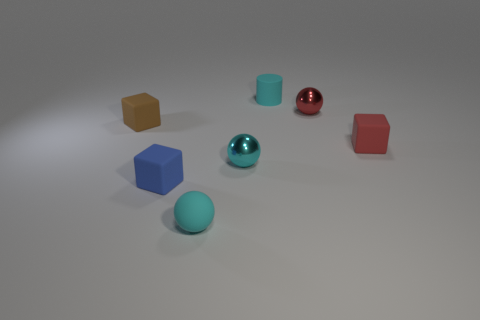Add 3 small blue matte cubes. How many objects exist? 10 Subtract all balls. How many objects are left? 4 Add 1 tiny blue matte cubes. How many tiny blue matte cubes exist? 2 Subtract 0 green blocks. How many objects are left? 7 Subtract all small rubber cubes. Subtract all tiny green balls. How many objects are left? 4 Add 1 cyan rubber balls. How many cyan rubber balls are left? 2 